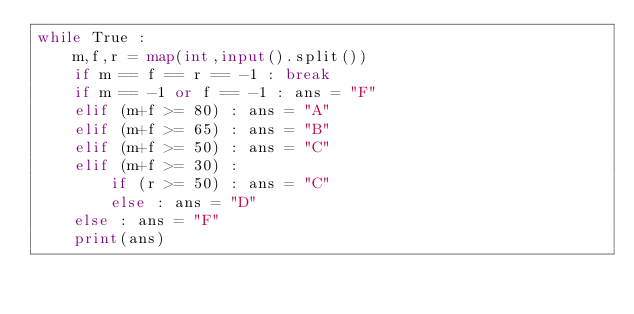Convert code to text. <code><loc_0><loc_0><loc_500><loc_500><_Python_>while True :
    m,f,r = map(int,input().split())
    if m == f == r == -1 : break
    if m == -1 or f == -1 : ans = "F"
    elif (m+f >= 80) : ans = "A"
    elif (m+f >= 65) : ans = "B"
    elif (m+f >= 50) : ans = "C"
    elif (m+f >= 30) :
        if (r >= 50) : ans = "C"
        else : ans = "D"
    else : ans = "F"
    print(ans)
    
</code> 